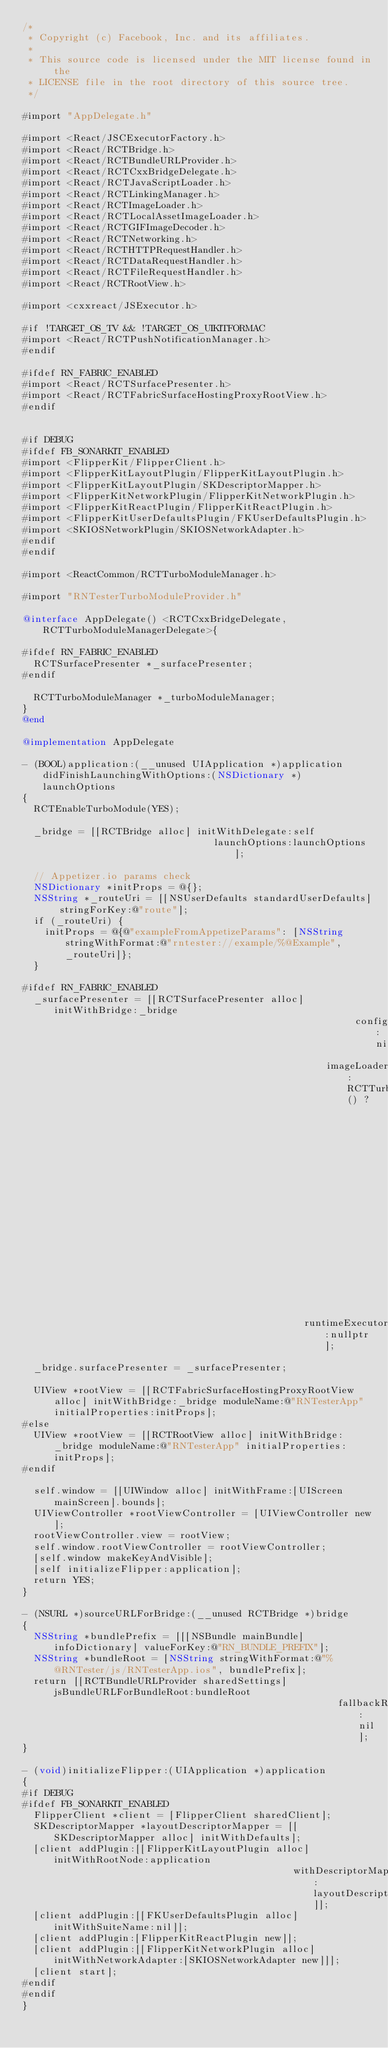Convert code to text. <code><loc_0><loc_0><loc_500><loc_500><_ObjectiveC_>/*
 * Copyright (c) Facebook, Inc. and its affiliates.
 *
 * This source code is licensed under the MIT license found in the
 * LICENSE file in the root directory of this source tree.
 */

#import "AppDelegate.h"

#import <React/JSCExecutorFactory.h>
#import <React/RCTBridge.h>
#import <React/RCTBundleURLProvider.h>
#import <React/RCTCxxBridgeDelegate.h>
#import <React/RCTJavaScriptLoader.h>
#import <React/RCTLinkingManager.h>
#import <React/RCTImageLoader.h>
#import <React/RCTLocalAssetImageLoader.h>
#import <React/RCTGIFImageDecoder.h>
#import <React/RCTNetworking.h>
#import <React/RCTHTTPRequestHandler.h>
#import <React/RCTDataRequestHandler.h>
#import <React/RCTFileRequestHandler.h>
#import <React/RCTRootView.h>

#import <cxxreact/JSExecutor.h>

#if !TARGET_OS_TV && !TARGET_OS_UIKITFORMAC
#import <React/RCTPushNotificationManager.h>
#endif

#ifdef RN_FABRIC_ENABLED
#import <React/RCTSurfacePresenter.h>
#import <React/RCTFabricSurfaceHostingProxyRootView.h>
#endif

  
#if DEBUG
#ifdef FB_SONARKIT_ENABLED
#import <FlipperKit/FlipperClient.h>
#import <FlipperKitLayoutPlugin/FlipperKitLayoutPlugin.h>
#import <FlipperKitLayoutPlugin/SKDescriptorMapper.h>
#import <FlipperKitNetworkPlugin/FlipperKitNetworkPlugin.h>
#import <FlipperKitReactPlugin/FlipperKitReactPlugin.h>
#import <FlipperKitUserDefaultsPlugin/FKUserDefaultsPlugin.h>
#import <SKIOSNetworkPlugin/SKIOSNetworkAdapter.h>
#endif
#endif

#import <ReactCommon/RCTTurboModuleManager.h>

#import "RNTesterTurboModuleProvider.h"

@interface AppDelegate() <RCTCxxBridgeDelegate, RCTTurboModuleManagerDelegate>{

#ifdef RN_FABRIC_ENABLED
  RCTSurfacePresenter *_surfacePresenter;
#endif

  RCTTurboModuleManager *_turboModuleManager;
}
@end

@implementation AppDelegate

- (BOOL)application:(__unused UIApplication *)application didFinishLaunchingWithOptions:(NSDictionary *)launchOptions
{
  RCTEnableTurboModule(YES);

  _bridge = [[RCTBridge alloc] initWithDelegate:self
                                  launchOptions:launchOptions];

  // Appetizer.io params check
  NSDictionary *initProps = @{};
  NSString *_routeUri = [[NSUserDefaults standardUserDefaults] stringForKey:@"route"];
  if (_routeUri) {
    initProps = @{@"exampleFromAppetizeParams": [NSString stringWithFormat:@"rntester://example/%@Example", _routeUri]};
  }

#ifdef RN_FABRIC_ENABLED
  _surfacePresenter = [[RCTSurfacePresenter alloc] initWithBridge:_bridge
                                                           config:nil
                                                      imageLoader:RCTTurboModuleEnabled() ?
                                                                  [_bridge moduleForName:@"RCTImageLoader"
                                                                  lazilyLoadIfNecessary:YES] : nil
                                                  runtimeExecutor:nullptr];

  _bridge.surfacePresenter = _surfacePresenter;

  UIView *rootView = [[RCTFabricSurfaceHostingProxyRootView alloc] initWithBridge:_bridge moduleName:@"RNTesterApp" initialProperties:initProps];
#else
  UIView *rootView = [[RCTRootView alloc] initWithBridge:_bridge moduleName:@"RNTesterApp" initialProperties:initProps];
#endif

  self.window = [[UIWindow alloc] initWithFrame:[UIScreen mainScreen].bounds];
  UIViewController *rootViewController = [UIViewController new];
  rootViewController.view = rootView;
  self.window.rootViewController = rootViewController;
  [self.window makeKeyAndVisible];
  [self initializeFlipper:application];
  return YES;
}

- (NSURL *)sourceURLForBridge:(__unused RCTBridge *)bridge
{
  NSString *bundlePrefix = [[[NSBundle mainBundle] infoDictionary] valueForKey:@"RN_BUNDLE_PREFIX"];
  NSString *bundleRoot = [NSString stringWithFormat:@"%@RNTester/js/RNTesterApp.ios", bundlePrefix];
  return [[RCTBundleURLProvider sharedSettings] jsBundleURLForBundleRoot:bundleRoot
                                                        fallbackResource:nil];
}

- (void)initializeFlipper:(UIApplication *)application
{
#if DEBUG
#ifdef FB_SONARKIT_ENABLED
  FlipperClient *client = [FlipperClient sharedClient];
  SKDescriptorMapper *layoutDescriptorMapper = [[SKDescriptorMapper alloc] initWithDefaults];
  [client addPlugin:[[FlipperKitLayoutPlugin alloc] initWithRootNode:application
                                                withDescriptorMapper:layoutDescriptorMapper]];
  [client addPlugin:[[FKUserDefaultsPlugin alloc] initWithSuiteName:nil]];
  [client addPlugin:[FlipperKitReactPlugin new]];
  [client addPlugin:[[FlipperKitNetworkPlugin alloc] initWithNetworkAdapter:[SKIOSNetworkAdapter new]]];
  [client start];
#endif
#endif
}
</code> 